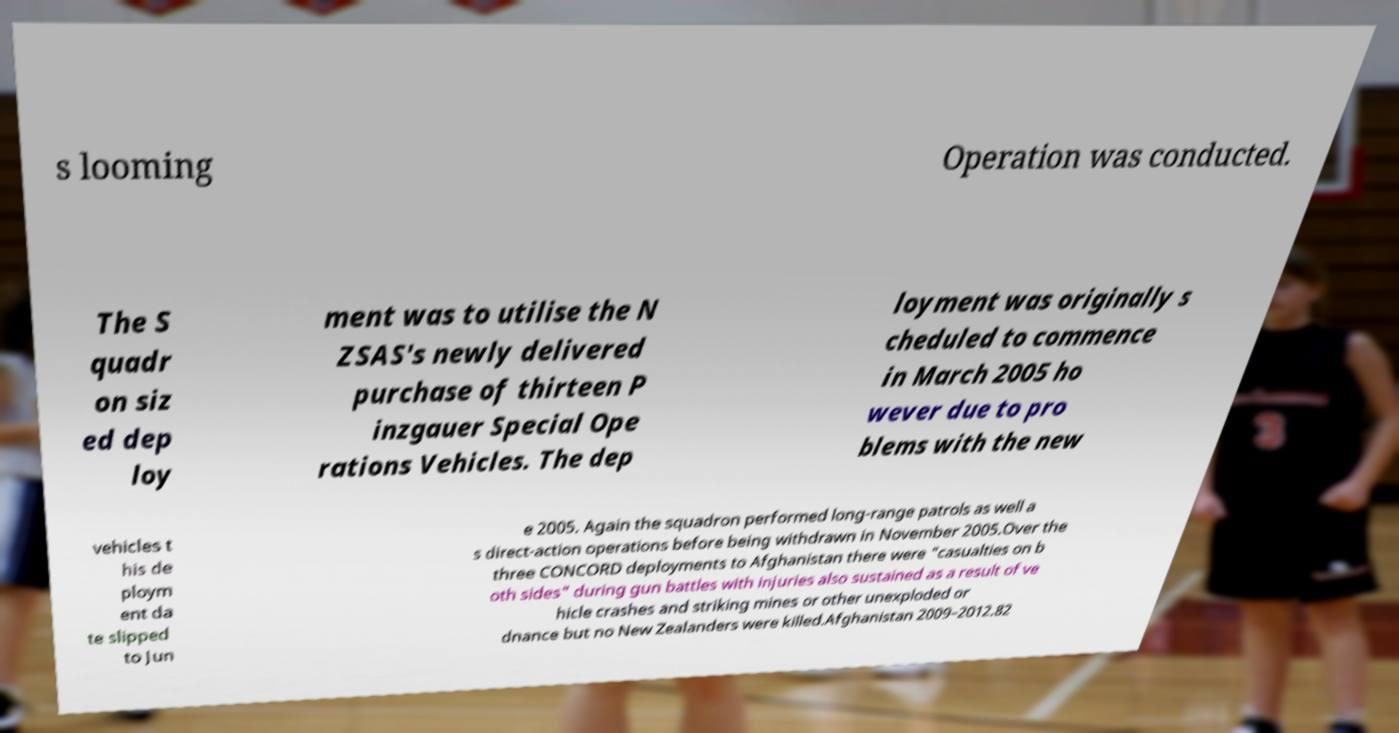Can you accurately transcribe the text from the provided image for me? s looming Operation was conducted. The S quadr on siz ed dep loy ment was to utilise the N ZSAS's newly delivered purchase of thirteen P inzgauer Special Ope rations Vehicles. The dep loyment was originally s cheduled to commence in March 2005 ho wever due to pro blems with the new vehicles t his de ploym ent da te slipped to Jun e 2005. Again the squadron performed long-range patrols as well a s direct-action operations before being withdrawn in November 2005.Over the three CONCORD deployments to Afghanistan there were "casualties on b oth sides" during gun battles with injuries also sustained as a result of ve hicle crashes and striking mines or other unexploded or dnance but no New Zealanders were killed.Afghanistan 2009–2012.82 